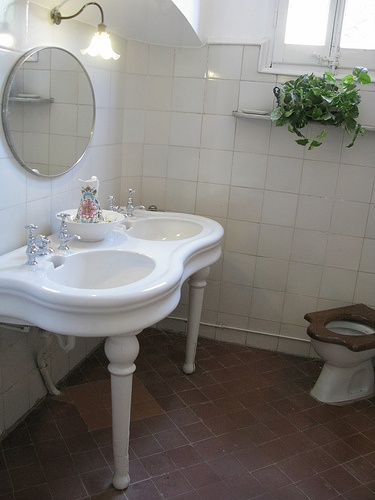Describe the objects in this image and their specific colors. I can see toilet in white, gray, and black tones, potted plant in white, black, gray, and darkgreen tones, sink in white, lightgray, and darkgray tones, sink in white, darkgray, and lightgray tones, and bowl in white, darkgray, and lightgray tones in this image. 